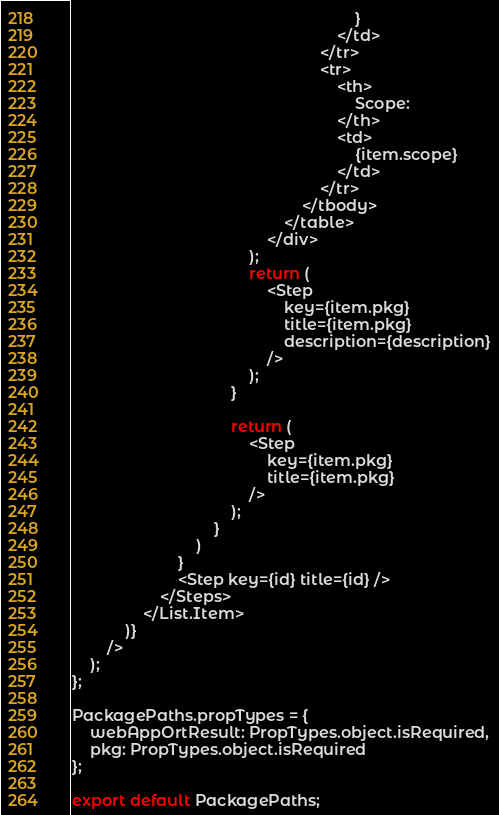<code> <loc_0><loc_0><loc_500><loc_500><_JavaScript_>                                                                }
                                                            </td>
                                                        </tr>
                                                        <tr>
                                                            <th>
                                                                Scope:
                                                            </th>
                                                            <td>
                                                                {item.scope}
                                                            </td>
                                                        </tr>
                                                    </tbody>
                                                </table>
                                            </div>
                                        );
                                        return (
                                            <Step
                                                key={item.pkg}
                                                title={item.pkg}
                                                description={description}
                                            />
                                        );
                                    }

                                    return (
                                        <Step
                                            key={item.pkg}
                                            title={item.pkg}
                                        />
                                    );
                                }
                            )
                        }
                        <Step key={id} title={id} />
                    </Steps>
                </List.Item>
            )}
        />
    );
};

PackagePaths.propTypes = {
    webAppOrtResult: PropTypes.object.isRequired,
    pkg: PropTypes.object.isRequired
};

export default PackagePaths;
</code> 